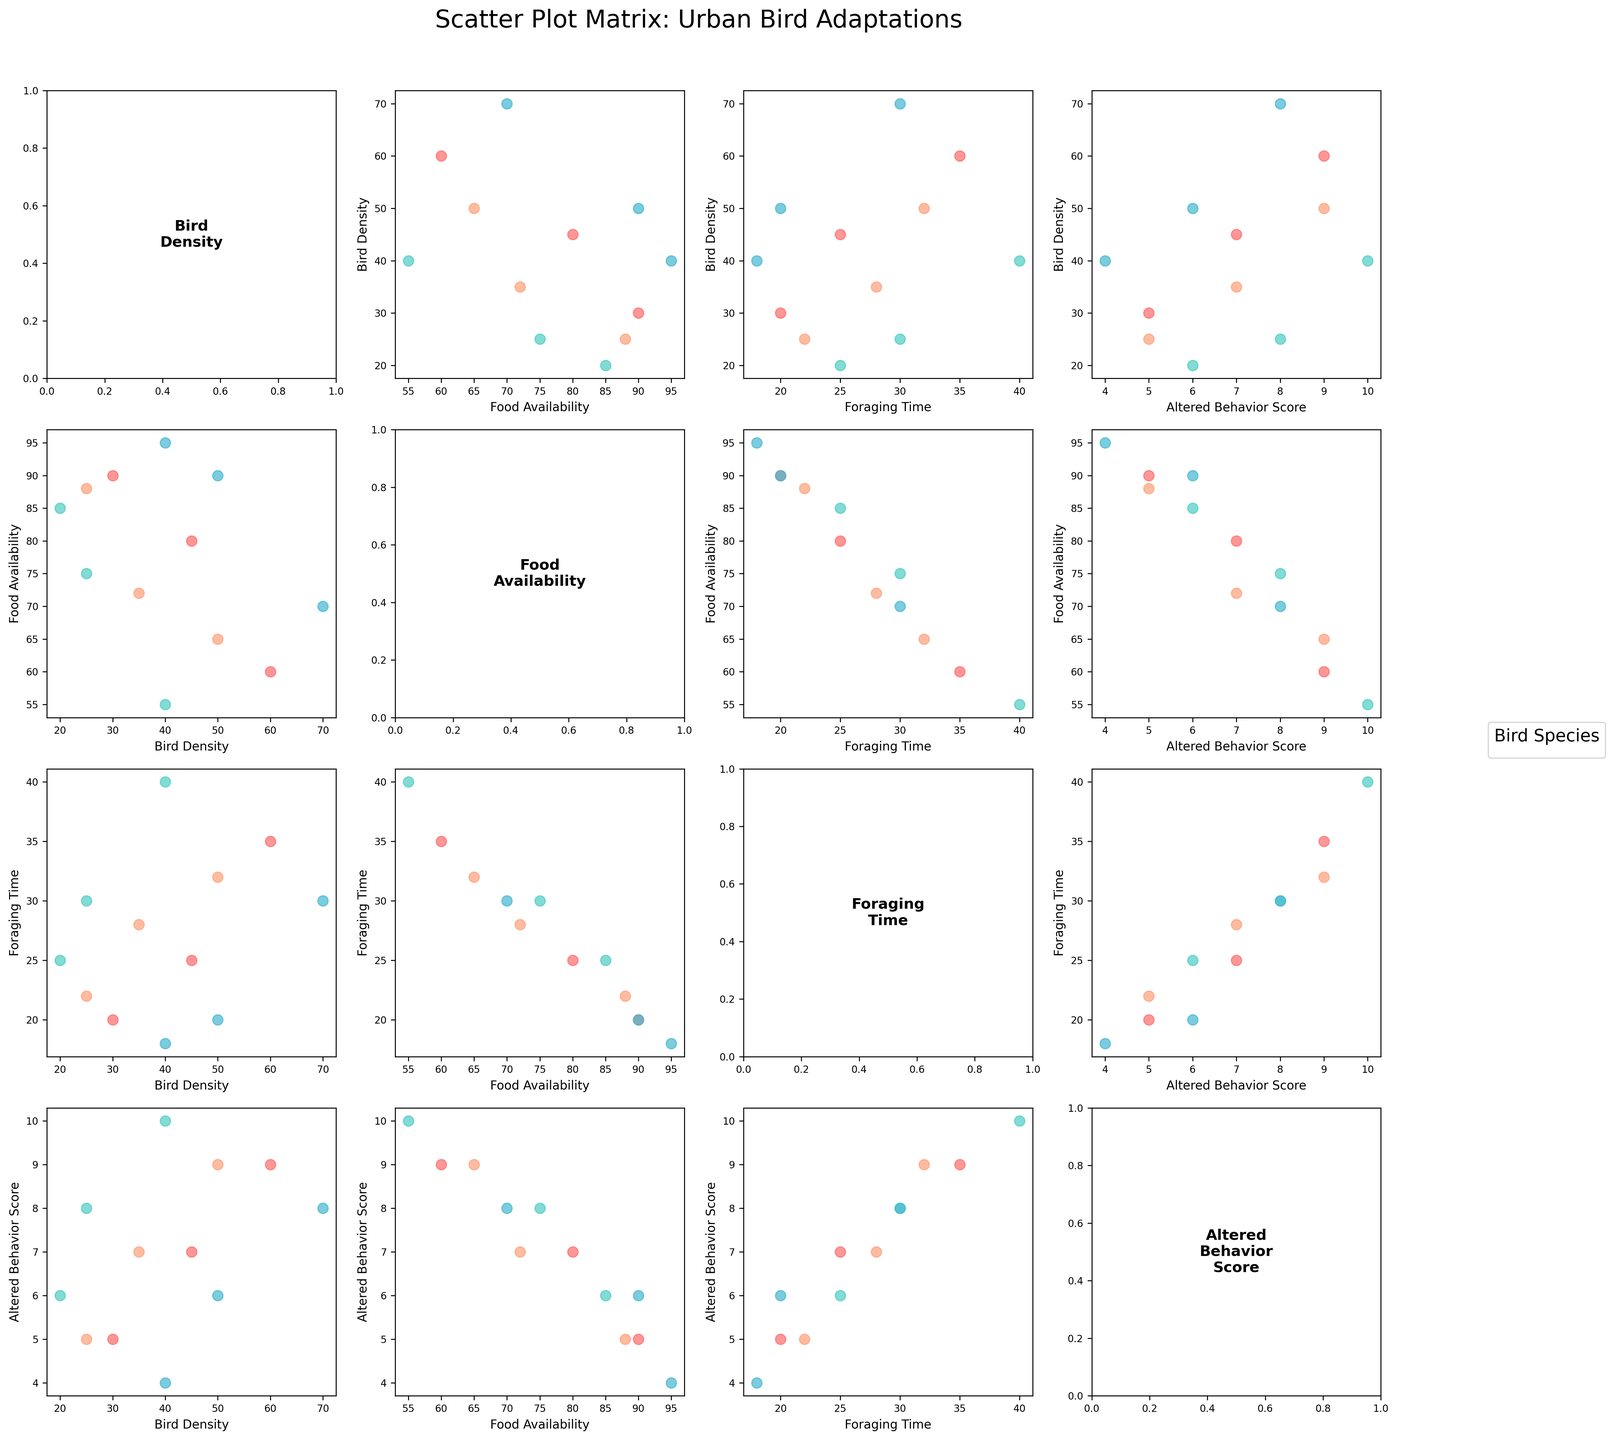What is the title of the figure? The title of the figure is written at the top of the plot, as a large and descriptive text. It is generally placed to give a succinct description of the content of the figure.
Answer: Scatter Plot Matrix: Urban Bird Adaptations Which bird species has the highest density in the Downtown location? To find this, look at the plot where the Bird_Density variable is on the y-axis and focus on the Downtown location points for all species. You will see that the Rock_Pigeon has the highest density in the Downtown location.
Answer: Rock_Pigeon Is there a noticeable trend between food availability and foraging time for American Robins across different locations? Examine the scatter plot where Food_Availability is on the x-axis and Foraging_Time is on the y-axis. Look for the unique color marker representing American Robin and check the pattern of the scatter points. For American Robins, you see a slight decline in Foraging_Time as Food_Availability increases, indicating a weak inverse relationship.
Answer: Yes, a weak inverse relationship Which bird species shows the widest spread in Altered_Behavior_Score, and how would you quantify this spread? Look at the scatter plots where Altered_Behavior_Score is on the y-axis and examine the spread of scores for each bird species. Rock_Pigeon shows scores from 4 to 8, while other species range within narrower margins. Quantify this by subtracting the minimum score from the maximum score for each species. Rock_Pigeon has the widest spread (8-4=4).
Answer: Rock_Pigeon (spread is 4) Compare the relationship between Bird Density and Altered Behavior Score for House Sparrows and European Starlings. Which one shows a stronger correlation, if any? Check the scatter plot with Bird_Density on the x-axis and Altered_Behavior_Score on the y-axis. Observe the trends for each species. House Sparrows show a rising trend as both variables increase. In contrast, European Starlings have a more dispersed pattern with less apparent correlation. Thus, House Sparrows demonstrate a stronger positive correlation.
Answer: House Sparrows How does the Central Park bird density compare between Rock Pigeons and House Sparrows? Look at the Bird_Density data points specifically for Central Park. Examine the points for Rock Pigeons and House Sparrows. For Central Park, Rock Pigeons have a density of 50, whereas House Sparrows have a density of 45, indicating Rock Pigeons have a slightly higher density.
Answer: Rock Pigeons are denser What is the relationship between Bird Density and Food Availability for birds in Suburban Areas? Examine the scatter plot with Bird_Density on the y-axis and Food_Availability on the x-axis, focusing on Suburban Area data points. The bird species data points predominantly show a positive trend that, as Food_Availability increases, Bird_Density tends to decrease. For example, House Sparrow has low Bird_Density when Food_Availability is high.
Answer: Inverse relationship Do European Starlings in Downtown locations show higher or lower foraging times compared to Central Park? Focus on the scatter plot where Foraging_Time is the y-axis, and compare data points of European Starling between Downtown and Central Park. European Starlings in Downtown locations tend to have higher Foraging_Time (around 40) than those in Central Park (around 30).
Answer: Higher in Downtown What combination of factors might predict a high Altered Behavior Score for urban birds? By examining the scatter plot matrix as a whole, one can look at the common patterns where Altered_Behavior_Score is high. Higher Bird_Density and lower Food_Availability seem to be common factors for high scores, especially noticeable in Downtown areas.
Answer: High bird density, low food availability 